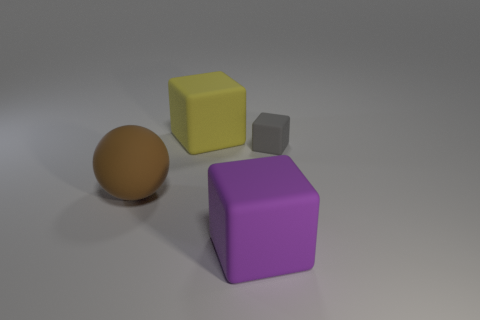How many things are large blocks that are in front of the gray object or blocks that are behind the large purple object?
Your answer should be very brief. 3. Are there more big yellow cubes left of the small gray matte object than brown balls that are on the left side of the brown rubber thing?
Your answer should be compact. Yes. Does the rubber thing that is on the right side of the large purple object have the same shape as the large object in front of the big brown thing?
Give a very brief answer. Yes. Is there a purple matte thing of the same size as the brown sphere?
Offer a very short reply. Yes. What number of red objects are either big balls or small rubber cubes?
Make the answer very short. 0. Are there any other things that have the same shape as the brown thing?
Give a very brief answer. No. What number of spheres are purple rubber objects or gray objects?
Offer a very short reply. 0. What color is the big matte block in front of the large yellow matte cube?
Give a very brief answer. Purple. What is the shape of the yellow object that is the same size as the purple cube?
Offer a terse response. Cube. There is a matte sphere; how many yellow cubes are in front of it?
Your answer should be compact. 0. 